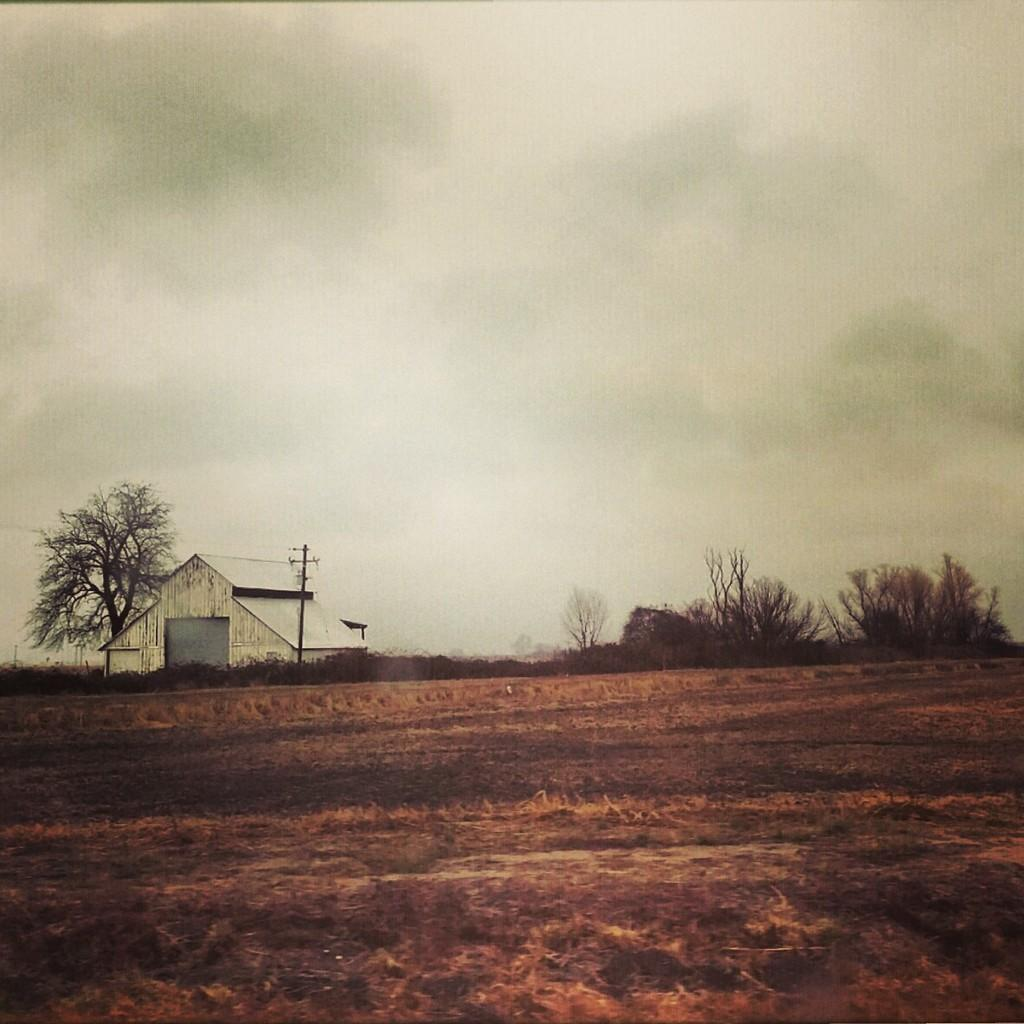What type of vegetation is present in the image? There is grass in the image. Are there any other natural elements in the image? Yes, there are trees in the image. What type of structure can be seen in the image? There is a fence in the image. What type of building is visible in the image? There is a house in the image. What other man-made object is present in the image? There is a light pole in the image. What can be seen in the background of the image? The sky is visible in the image. From what perspective is the image likely taken? The image is likely taken from the ground. What type of pen is being used to write on the bridge in the image? There is no pen or bridge present in the image. 